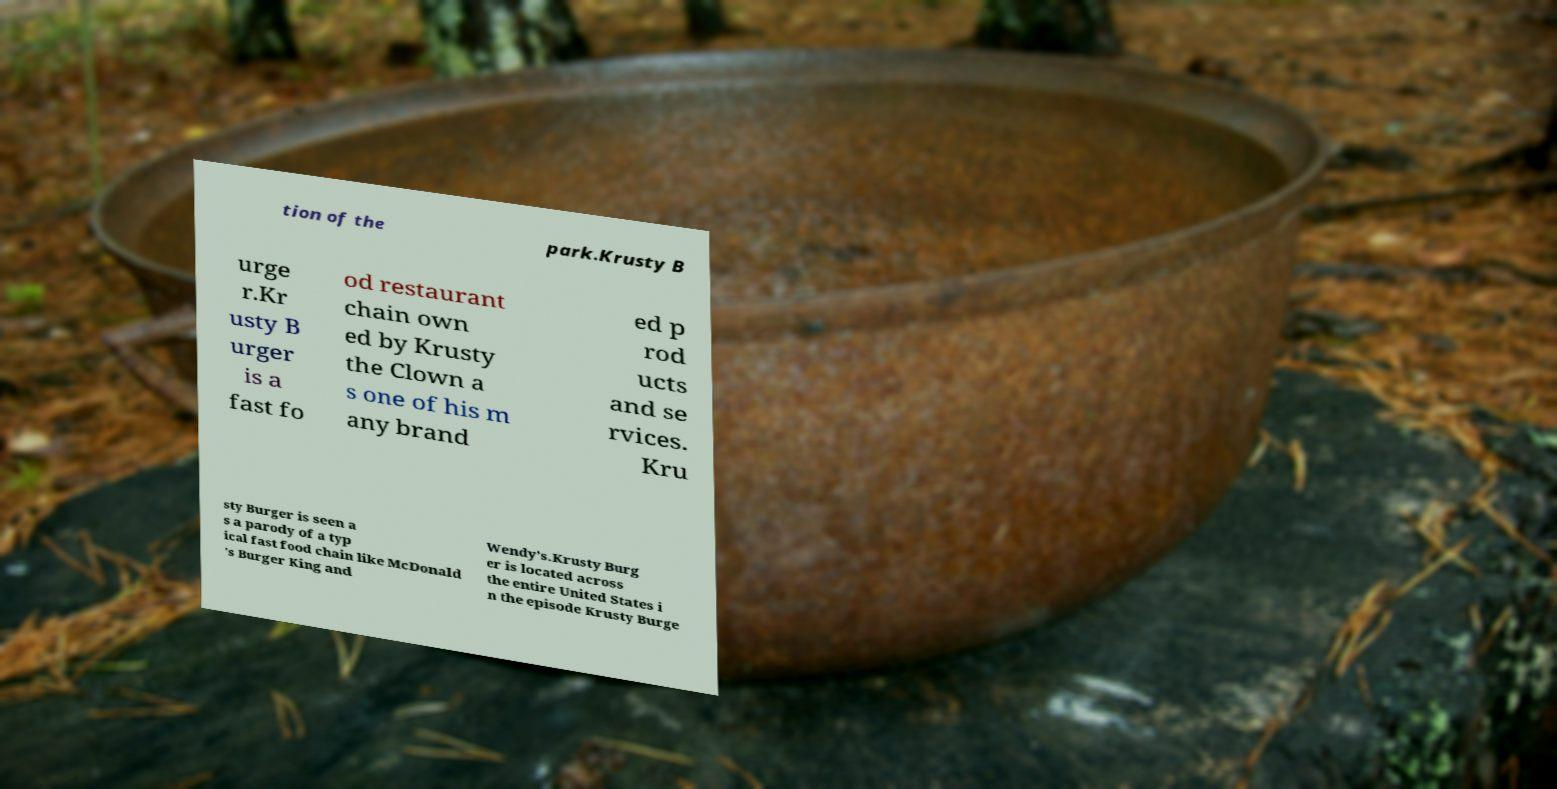Please read and relay the text visible in this image. What does it say? tion of the park.Krusty B urge r.Kr usty B urger is a fast fo od restaurant chain own ed by Krusty the Clown a s one of his m any brand ed p rod ucts and se rvices. Kru sty Burger is seen a s a parody of a typ ical fast food chain like McDonald 's Burger King and Wendy’s.Krusty Burg er is located across the entire United States i n the episode Krusty Burge 